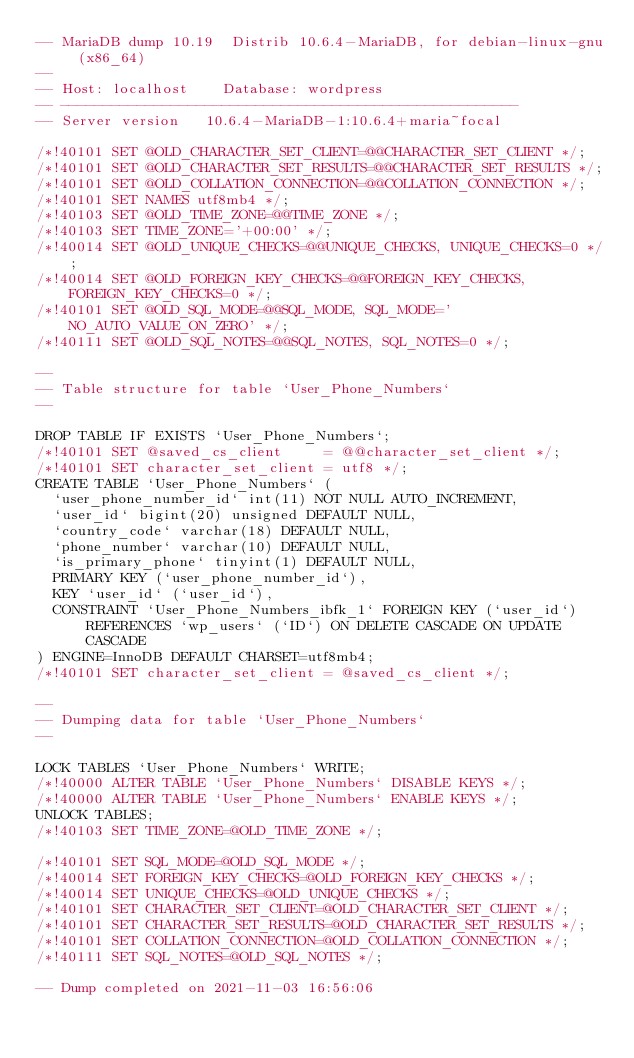Convert code to text. <code><loc_0><loc_0><loc_500><loc_500><_SQL_>-- MariaDB dump 10.19  Distrib 10.6.4-MariaDB, for debian-linux-gnu (x86_64)
--
-- Host: localhost    Database: wordpress
-- ------------------------------------------------------
-- Server version	10.6.4-MariaDB-1:10.6.4+maria~focal

/*!40101 SET @OLD_CHARACTER_SET_CLIENT=@@CHARACTER_SET_CLIENT */;
/*!40101 SET @OLD_CHARACTER_SET_RESULTS=@@CHARACTER_SET_RESULTS */;
/*!40101 SET @OLD_COLLATION_CONNECTION=@@COLLATION_CONNECTION */;
/*!40101 SET NAMES utf8mb4 */;
/*!40103 SET @OLD_TIME_ZONE=@@TIME_ZONE */;
/*!40103 SET TIME_ZONE='+00:00' */;
/*!40014 SET @OLD_UNIQUE_CHECKS=@@UNIQUE_CHECKS, UNIQUE_CHECKS=0 */;
/*!40014 SET @OLD_FOREIGN_KEY_CHECKS=@@FOREIGN_KEY_CHECKS, FOREIGN_KEY_CHECKS=0 */;
/*!40101 SET @OLD_SQL_MODE=@@SQL_MODE, SQL_MODE='NO_AUTO_VALUE_ON_ZERO' */;
/*!40111 SET @OLD_SQL_NOTES=@@SQL_NOTES, SQL_NOTES=0 */;

--
-- Table structure for table `User_Phone_Numbers`
--

DROP TABLE IF EXISTS `User_Phone_Numbers`;
/*!40101 SET @saved_cs_client     = @@character_set_client */;
/*!40101 SET character_set_client = utf8 */;
CREATE TABLE `User_Phone_Numbers` (
  `user_phone_number_id` int(11) NOT NULL AUTO_INCREMENT,
  `user_id` bigint(20) unsigned DEFAULT NULL,
  `country_code` varchar(18) DEFAULT NULL,
  `phone_number` varchar(10) DEFAULT NULL,
  `is_primary_phone` tinyint(1) DEFAULT NULL,
  PRIMARY KEY (`user_phone_number_id`),
  KEY `user_id` (`user_id`),
  CONSTRAINT `User_Phone_Numbers_ibfk_1` FOREIGN KEY (`user_id`) REFERENCES `wp_users` (`ID`) ON DELETE CASCADE ON UPDATE CASCADE
) ENGINE=InnoDB DEFAULT CHARSET=utf8mb4;
/*!40101 SET character_set_client = @saved_cs_client */;

--
-- Dumping data for table `User_Phone_Numbers`
--

LOCK TABLES `User_Phone_Numbers` WRITE;
/*!40000 ALTER TABLE `User_Phone_Numbers` DISABLE KEYS */;
/*!40000 ALTER TABLE `User_Phone_Numbers` ENABLE KEYS */;
UNLOCK TABLES;
/*!40103 SET TIME_ZONE=@OLD_TIME_ZONE */;

/*!40101 SET SQL_MODE=@OLD_SQL_MODE */;
/*!40014 SET FOREIGN_KEY_CHECKS=@OLD_FOREIGN_KEY_CHECKS */;
/*!40014 SET UNIQUE_CHECKS=@OLD_UNIQUE_CHECKS */;
/*!40101 SET CHARACTER_SET_CLIENT=@OLD_CHARACTER_SET_CLIENT */;
/*!40101 SET CHARACTER_SET_RESULTS=@OLD_CHARACTER_SET_RESULTS */;
/*!40101 SET COLLATION_CONNECTION=@OLD_COLLATION_CONNECTION */;
/*!40111 SET SQL_NOTES=@OLD_SQL_NOTES */;

-- Dump completed on 2021-11-03 16:56:06
</code> 